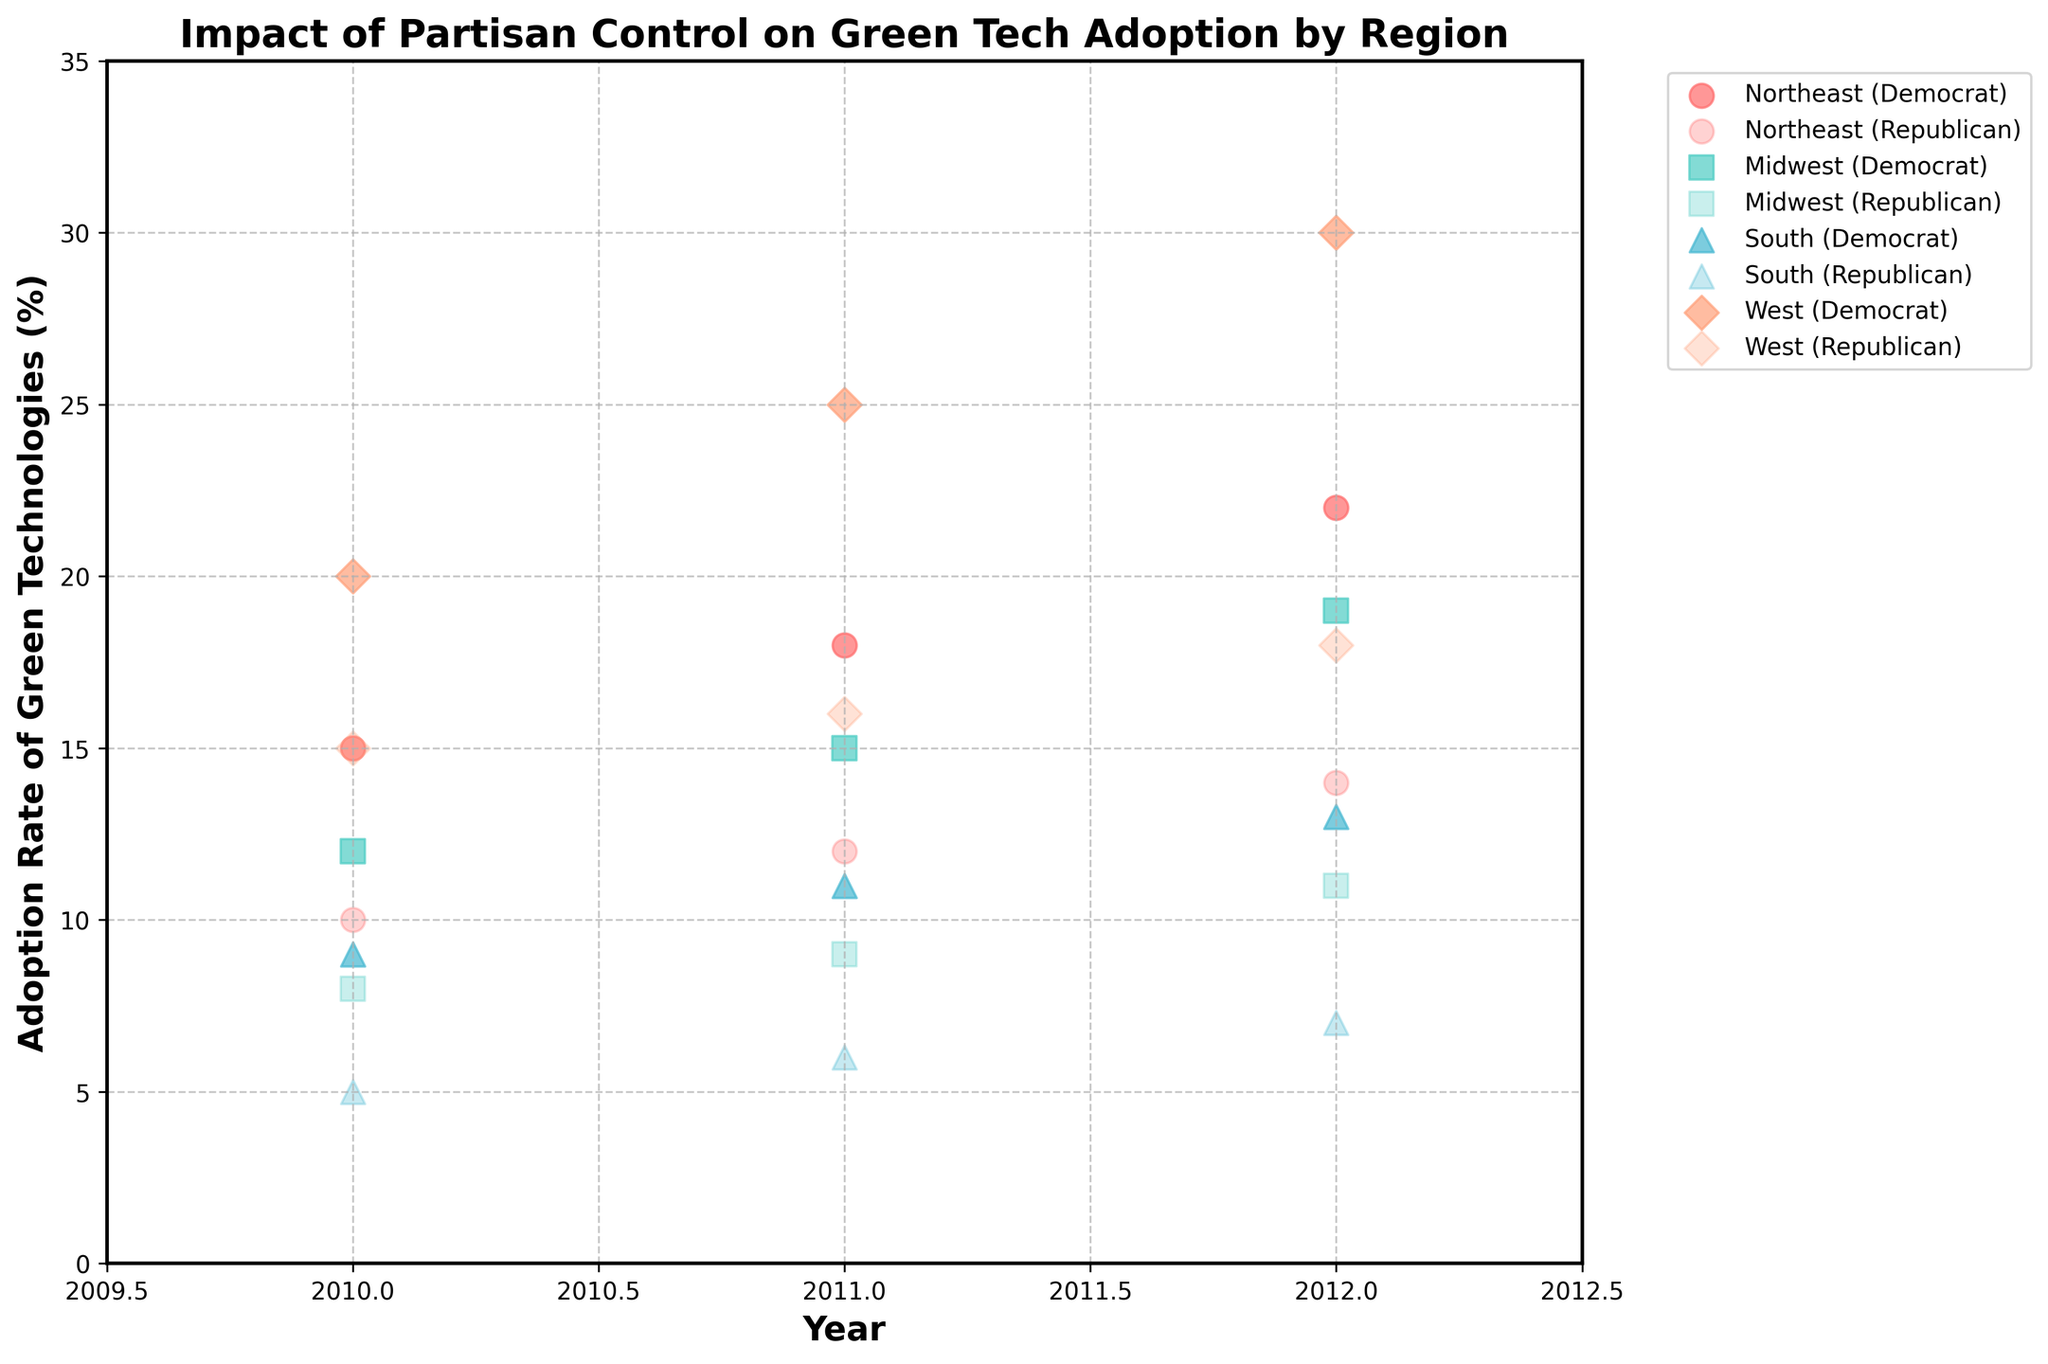Which region shows the highest adoption rate of green technologies under Democrat control in 2012? By looking at the Democrat data points in 2012 for all regions, the West shows the highest adoption rate, reaching 30%.
Answer: West How does the adoption rate of green technologies in the Midwest compare between 2010 and 2012 under Republican control? In 2010, the adoption rate is 8%, while in 2012, it is 11%. The adoption rate increased by 3%.
Answer: Increased by 3% Which region had the smallest adoption rate difference between Democrat and Republican control in 2011? In 2011, the adoption rates for Democrats and Republicans respectively are: Northeast (18%, 12%), Midwest (15%, 9%), South (11%, 6%), and West (25%, 16%). The smallest difference (5%) is in the South.
Answer: South What is the average adoption rate of green technologies under Democrat control across all regions in 2011? Summing up the rates for all regions in 2011 under Democrat control: Northeast (18), Midwest (15), South (11), and West (25). Average = (18 + 15 + 11 + 25) / 4 = 69 / 4 = 17.25.
Answer: 17.25% Which region experienced the greatest overall increase in adoption rate of green technologies under Democrat control from 2010 to 2012? Calculating the increase for each region under Democrat control from 2010 to 2012: Northeast (22-15), Midwest (19-12), South (13-9), and West (30-20). The increases are 7%, 7%, 4%, and 10% respectively. The greatest increase is in the West at 10%.
Answer: West Comparing the adoption rate of green technologies in the Northeast in 2010, which party had a higher rate? In 2010, the adoption rate in the Northeast is 15% for Democrats and 10% for Republicans. Democrats had a higher adoption rate.
Answer: Democrats What is the total adoption rate of green technologies under Republican control across all regions in 2012? The rates for Republicans in 2012 across regions are: Northeast (14), Midwest (11), South (7), and West (18). Total = 14 + 11 + 7 + 18 = 50.
Answer: 50% In which year did the South region have the highest adoption rate of green technologies under Democrat control? For the South under Democrat control, the rates are 9% in 2010, 11% in 2011, and 13% in 2012. The highest rate was in 2012.
Answer: 2012 What trend can be observed in the adoption rate of green technologies in the West under Republican control from 2010 to 2012? The adoption rates in the West under Republican control are 15% in 2010, 16% in 2011, and 18% in 2012. There is a consistent increasing trend.
Answer: Increasing How does the adoption rate of green technologies in the Northeast in 2012 under Republican control compare to the Midwest in the same year? In 2012, the adoption rate in the Northeast is 14% and in the Midwest is 11% under Republican control. The Northeast has a higher rate.
Answer: Northeast 